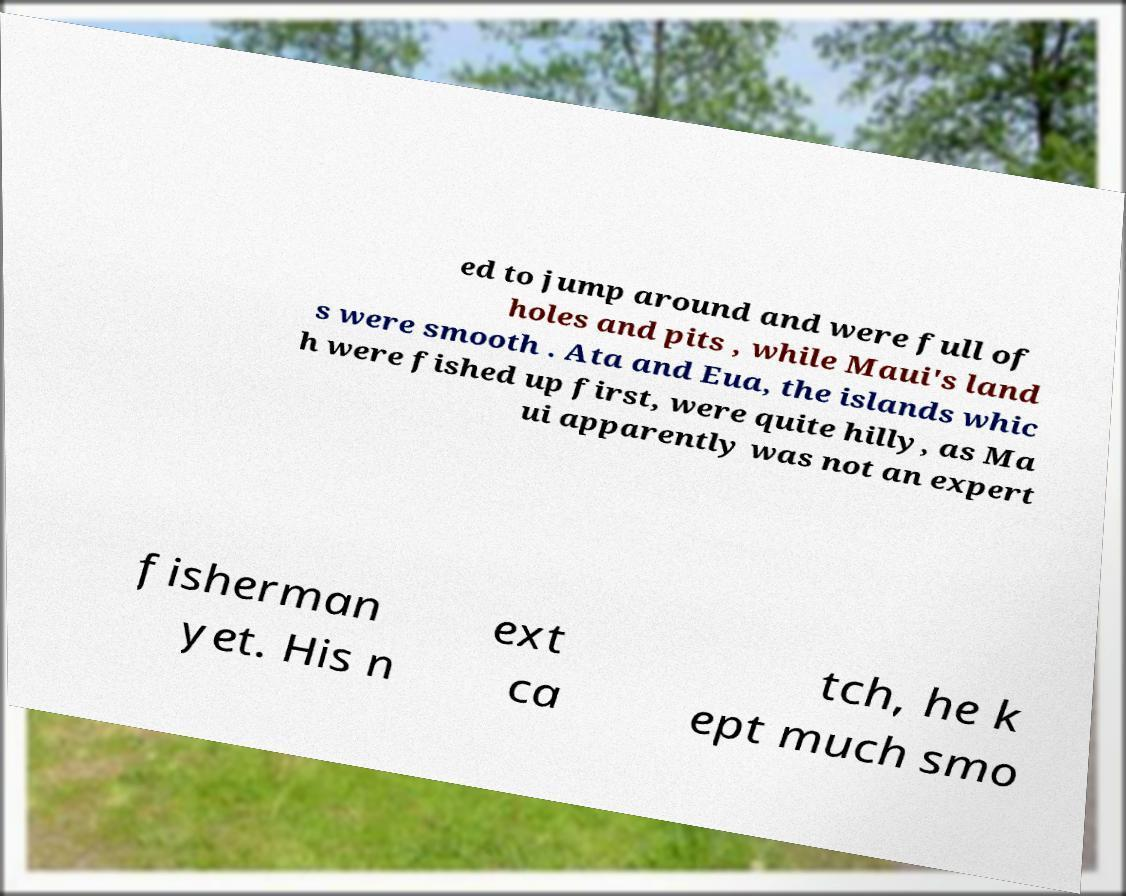What messages or text are displayed in this image? I need them in a readable, typed format. ed to jump around and were full of holes and pits , while Maui's land s were smooth . Ata and Eua, the islands whic h were fished up first, were quite hilly, as Ma ui apparently was not an expert fisherman yet. His n ext ca tch, he k ept much smo 